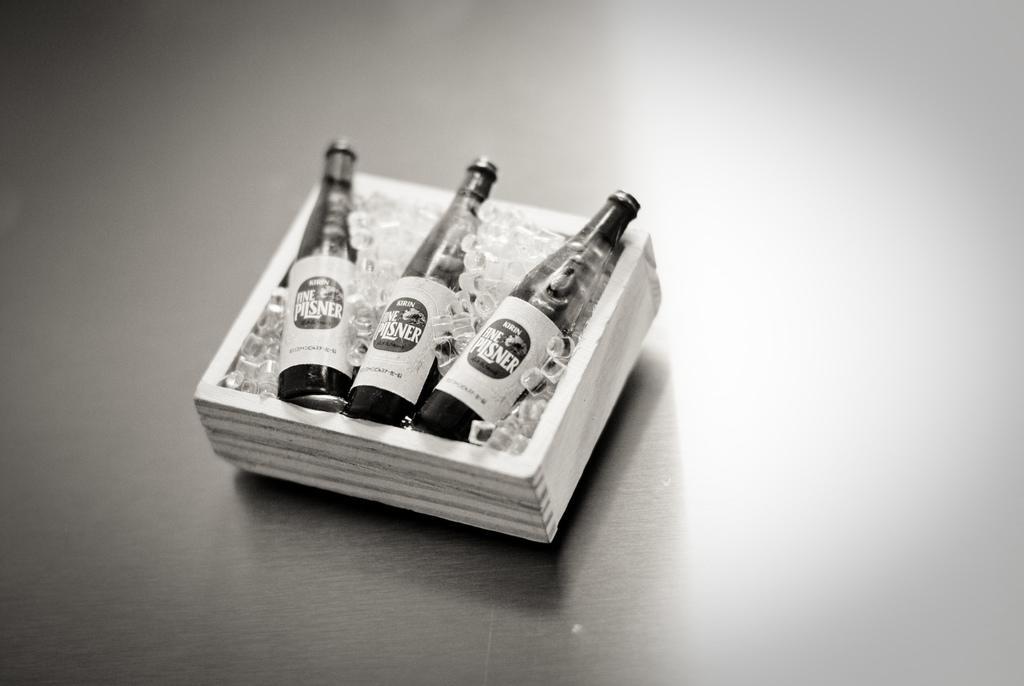Could you give a brief overview of what you see in this image? In the center of the image we can see beverage bottles placed in container. 